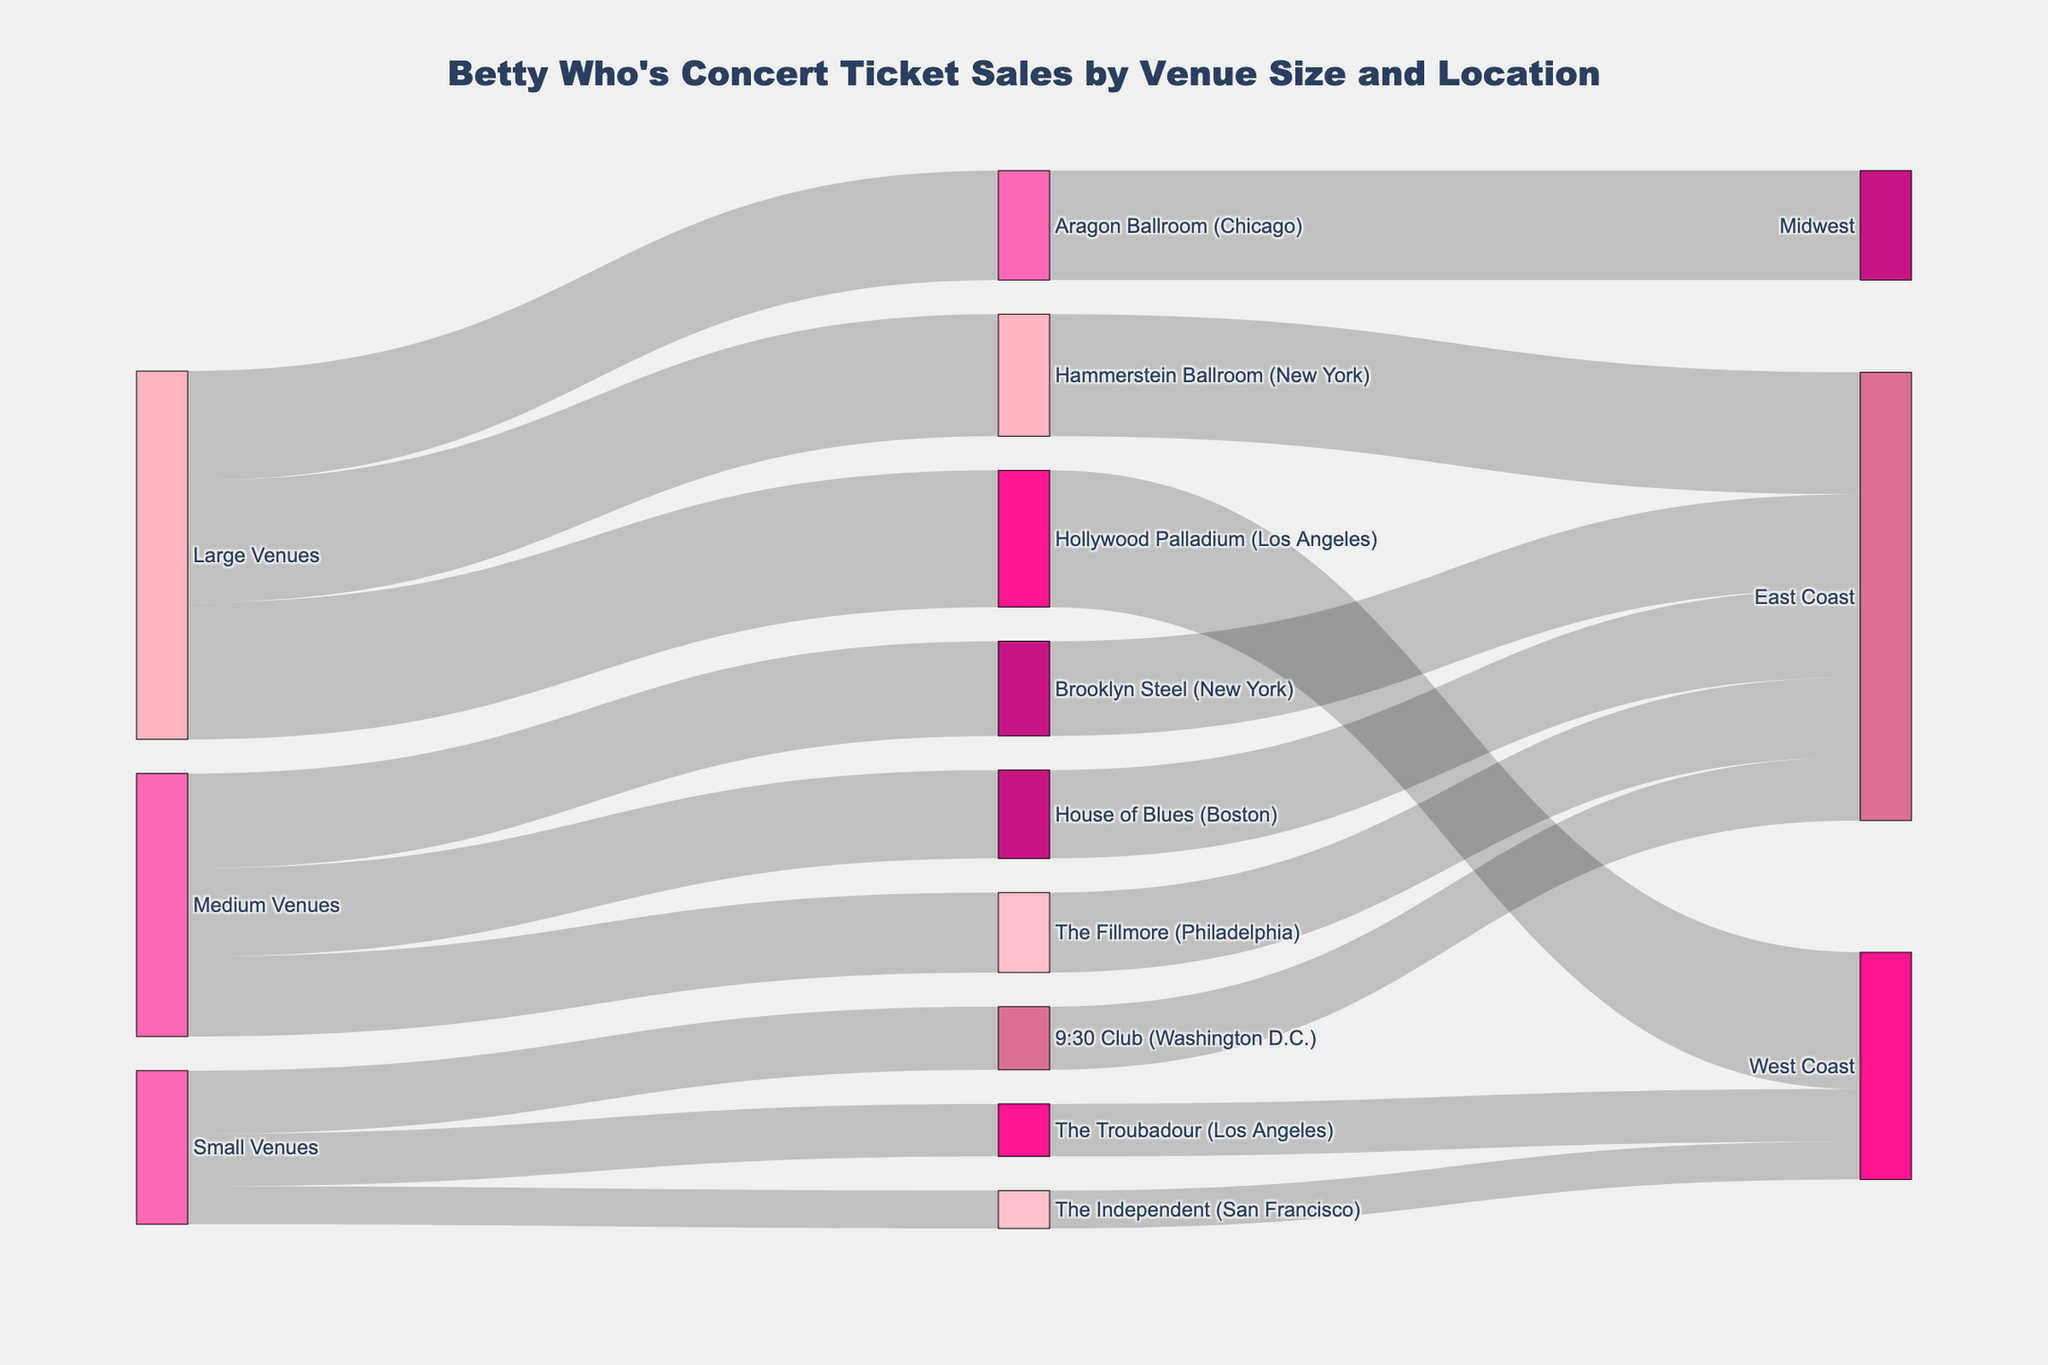What are the total ticket sales for Small Venues? To find the total sales for Small Venues, sum up the values linked to Small Venues. These values are 2500 for The Troubadour (Los Angeles), 3000 for 9:30 Club (Washington D.C.), and 1800 for The Independent (San Francisco). So, 2500 + 3000 + 1800 = 7300.
Answer: 7300 How many tickets were sold at venues located on the East Coast? Sum up the ticket sales for East Coast venues: 3000 for 9:30 Club (Washington D.C.), 4500 for Brooklyn Steel (New York), 3800 for The Fillmore (Philadelphia), 4200 for House of Blues (Boston), and 5800 for Hammerstein Ballroom (New York). So, 3000 + 4500 + 3800 + 4200 + 5800 = 21300.
Answer: 21300 Which venue had the highest number of ticket sales? Compare the ticket sales for all venues. Hollywood Palladium (Los Angeles) has the highest ticket sales with a value of 6500.
Answer: Hollywood Palladium How many more tickets were sold at Large Venues compared to Small Venues? First, sum up the ticket sales for Large Venues: 6500 for Hollywood Palladium (Los Angeles), 5800 for Hammerstein Ballroom (New York), and 5200 for Aragon Ballroom (Chicago). So, 6500 + 5800 + 5200 = 17500. Then for Small Venues, 2500 for The Troubadour (Los Angeles), 3000 for 9:30 Club (Washington D.C.), and 1800 for The Independent (San Francisco), which is 2500 + 3000 + 1800 = 7300. Now the difference is 17500 - 7300 = 10200.
Answer: 10200 Which venue in New York had higher ticket sales? Compare the ticket sales of Brooklyn Steel and Hammerstein Ballroom, both in New York. Hammerstein Ballroom has 5800 while Brooklyn Steel has 4500. So, Hammerstein Ballroom has higher ticket sales.
Answer: Hammerstein Ballroom What's the average number of ticket sales for Medium Venues? Sum up the ticket sales for Medium Venues: 4500 for Brooklyn Steel (New York), 3800 for The Fillmore (Philadelphia), and 4200 for House of Blues (Boston). So, 4500 + 3800 + 4200 = 12500. The average is 12500 / 3 = 4166.67.
Answer: 4166.67 Which coast has the highest total ticket sales? Calculate the total ticket sales for each coast. West Coast: 2500 for The Troubadour (Los Angeles), 1800 for The Independent (San Francisco), and 6500 for Hollywood Palladium (Los Angeles), summing to 2500 + 1800 + 6500 = 10800. East Coast: 3000 for 9:30 Club (Washington D.C.), 4500 for Brooklyn Steel (New York), 3800 for The Fillmore (Philadelphia), 4200 for House of Blues (Boston), and 5800 for Hammerstein Ballroom (New York), summing to 3000 + 4500 + 3800 + 4200 + 5800 = 21300. Midwest has just 5200 for Aragon Ballroom (Chicago). The East Coast has the highest total ticket sales.
Answer: East Coast If ticket sales from the West Coast were doubled, what would the new total be? Current West Coast sales are 10800 (2500 for The Troubadour, 1800 for The Independent, 6500 for Hollywood Palladium). Doubling this gives 10800 x 2 = 21600.
Answer: 21600 Which venue sold exactly 3800 tickets? Look for the venue name linked to the value 3800. The Fillmore (Philadelphia) sold exactly 3800 tickets.
Answer: The Fillmore (Philadelphia) 